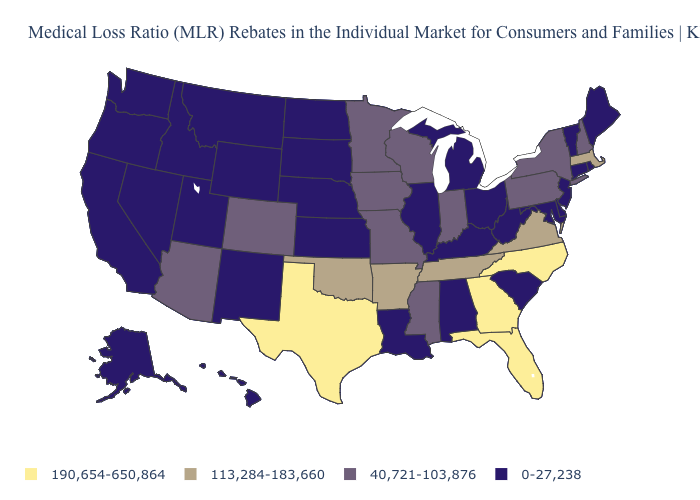Name the states that have a value in the range 190,654-650,864?
Quick response, please. Florida, Georgia, North Carolina, Texas. Name the states that have a value in the range 40,721-103,876?
Write a very short answer. Arizona, Colorado, Indiana, Iowa, Minnesota, Mississippi, Missouri, New Hampshire, New York, Pennsylvania, Wisconsin. Does the first symbol in the legend represent the smallest category?
Short answer required. No. What is the value of Connecticut?
Concise answer only. 0-27,238. What is the highest value in the MidWest ?
Be succinct. 40,721-103,876. What is the value of North Carolina?
Short answer required. 190,654-650,864. What is the highest value in the USA?
Answer briefly. 190,654-650,864. Does the first symbol in the legend represent the smallest category?
Write a very short answer. No. What is the lowest value in the USA?
Short answer required. 0-27,238. Name the states that have a value in the range 113,284-183,660?
Give a very brief answer. Arkansas, Massachusetts, Oklahoma, Tennessee, Virginia. Among the states that border Michigan , does Indiana have the highest value?
Short answer required. Yes. Does Iowa have the highest value in the USA?
Keep it brief. No. Does Colorado have the lowest value in the USA?
Quick response, please. No. What is the highest value in the MidWest ?
Quick response, please. 40,721-103,876. 